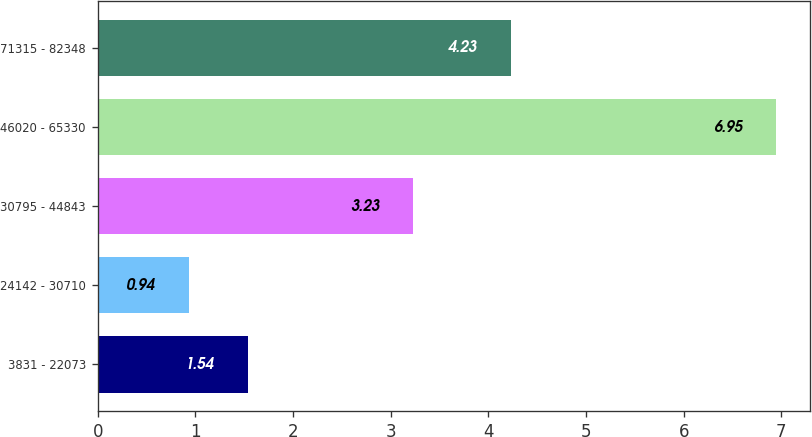Convert chart to OTSL. <chart><loc_0><loc_0><loc_500><loc_500><bar_chart><fcel>3831 - 22073<fcel>24142 - 30710<fcel>30795 - 44843<fcel>46020 - 65330<fcel>71315 - 82348<nl><fcel>1.54<fcel>0.94<fcel>3.23<fcel>6.95<fcel>4.23<nl></chart> 